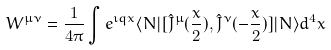<formula> <loc_0><loc_0><loc_500><loc_500>W ^ { \mu \nu } = \frac { 1 } { 4 \pi } \int \nolimits e ^ { \imath q x } \langle N | [ { \hat { J } } ^ { \mu } ( \frac { x } { 2 } ) , { \hat { J } } ^ { \nu } ( - \frac { x } { 2 } ) ] | N \rangle d ^ { 4 } x</formula> 